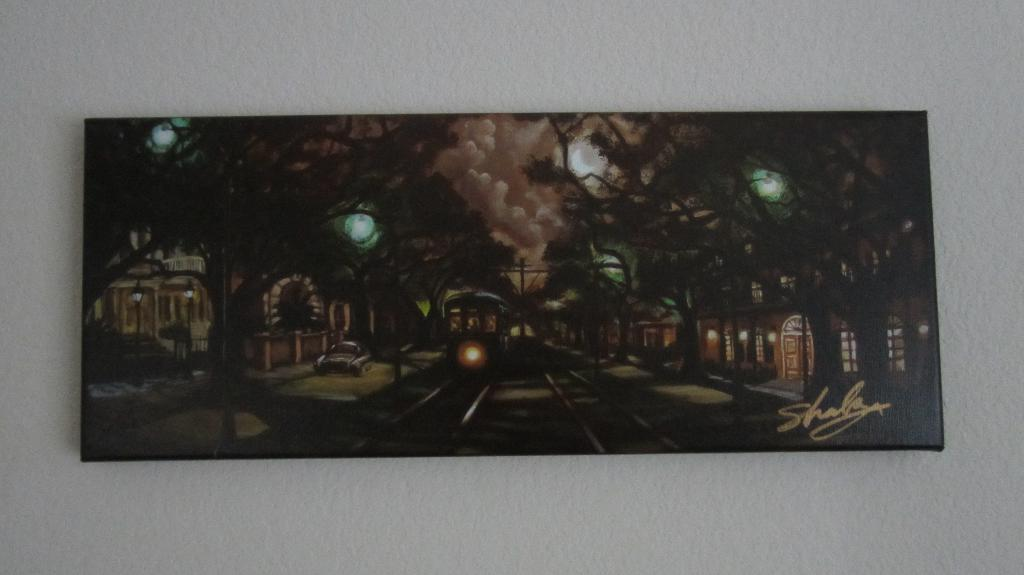<image>
Present a compact description of the photo's key features. A dark panting is signed by the artist shala. 